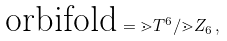<formula> <loc_0><loc_0><loc_500><loc_500>\text {orbifold} = \mathbb { m } { T } ^ { 6 } / \mathbb { m } { Z } _ { 6 } \, ,</formula> 